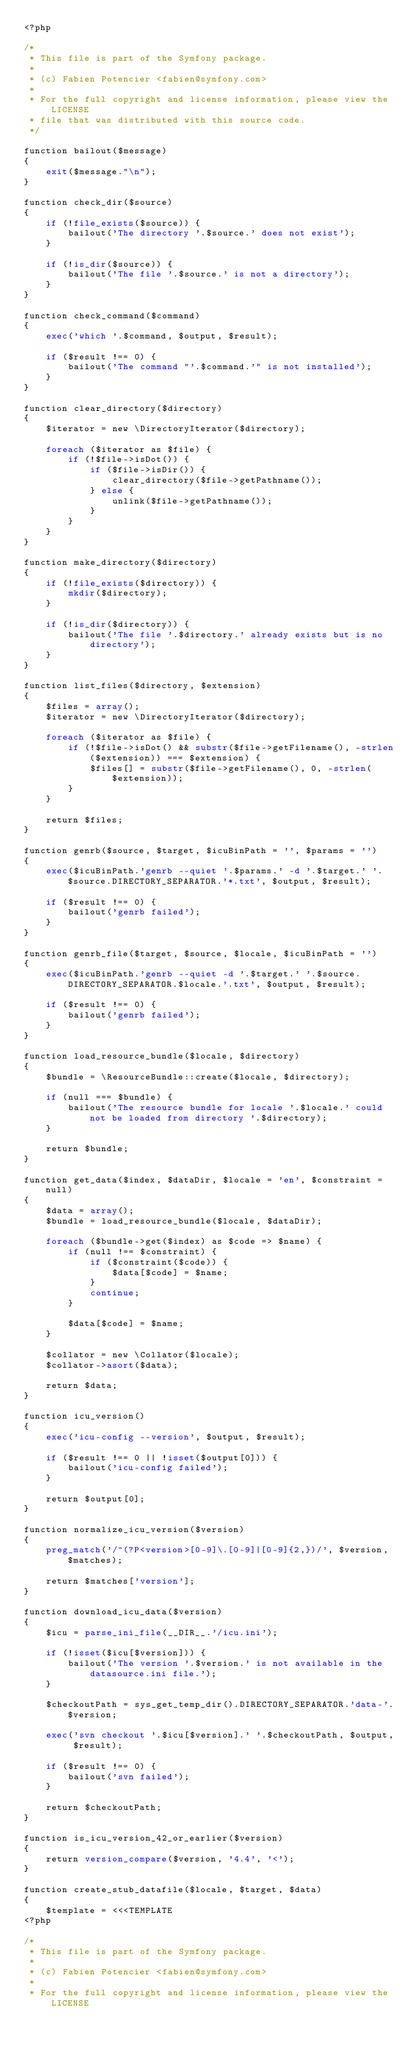Convert code to text. <code><loc_0><loc_0><loc_500><loc_500><_PHP_><?php

/*
 * This file is part of the Symfony package.
 *
 * (c) Fabien Potencier <fabien@symfony.com>
 *
 * For the full copyright and license information, please view the LICENSE
 * file that was distributed with this source code.
 */

function bailout($message)
{
    exit($message."\n");
}

function check_dir($source)
{
    if (!file_exists($source)) {
        bailout('The directory '.$source.' does not exist');
    }

    if (!is_dir($source)) {
        bailout('The file '.$source.' is not a directory');
    }
}

function check_command($command)
{
    exec('which '.$command, $output, $result);

    if ($result !== 0) {
        bailout('The command "'.$command.'" is not installed');
    }
}

function clear_directory($directory)
{
    $iterator = new \DirectoryIterator($directory);

    foreach ($iterator as $file) {
        if (!$file->isDot()) {
            if ($file->isDir()) {
                clear_directory($file->getPathname());
            } else {
                unlink($file->getPathname());
            }
        }
    }
}

function make_directory($directory)
{
    if (!file_exists($directory)) {
        mkdir($directory);
    }

    if (!is_dir($directory)) {
        bailout('The file '.$directory.' already exists but is no directory');
    }
}

function list_files($directory, $extension)
{
    $files = array();
    $iterator = new \DirectoryIterator($directory);

    foreach ($iterator as $file) {
        if (!$file->isDot() && substr($file->getFilename(), -strlen($extension)) === $extension) {
            $files[] = substr($file->getFilename(), 0, -strlen($extension));
        }
    }

    return $files;
}

function genrb($source, $target, $icuBinPath = '', $params = '')
{
    exec($icuBinPath.'genrb --quiet '.$params.' -d '.$target.' '.$source.DIRECTORY_SEPARATOR.'*.txt', $output, $result);

    if ($result !== 0) {
        bailout('genrb failed');
    }
}

function genrb_file($target, $source, $locale, $icuBinPath = '')
{
    exec($icuBinPath.'genrb --quiet -d '.$target.' '.$source.DIRECTORY_SEPARATOR.$locale.'.txt', $output, $result);

    if ($result !== 0) {
        bailout('genrb failed');
    }
}

function load_resource_bundle($locale, $directory)
{
    $bundle = \ResourceBundle::create($locale, $directory);

    if (null === $bundle) {
        bailout('The resource bundle for locale '.$locale.' could not be loaded from directory '.$directory);
    }

    return $bundle;
}

function get_data($index, $dataDir, $locale = 'en', $constraint = null)
{
    $data = array();
    $bundle = load_resource_bundle($locale, $dataDir);

    foreach ($bundle->get($index) as $code => $name) {
        if (null !== $constraint) {
            if ($constraint($code)) {
                $data[$code] = $name;
            }
            continue;
        }

        $data[$code] = $name;
    }

    $collator = new \Collator($locale);
    $collator->asort($data);

    return $data;
}

function icu_version()
{
    exec('icu-config --version', $output, $result);

    if ($result !== 0 || !isset($output[0])) {
        bailout('icu-config failed');
    }

    return $output[0];
}

function normalize_icu_version($version)
{
    preg_match('/^(?P<version>[0-9]\.[0-9]|[0-9]{2,})/', $version, $matches);

    return $matches['version'];
}

function download_icu_data($version)
{
    $icu = parse_ini_file(__DIR__.'/icu.ini');

    if (!isset($icu[$version])) {
        bailout('The version '.$version.' is not available in the datasource.ini file.');
    }

    $checkoutPath = sys_get_temp_dir().DIRECTORY_SEPARATOR.'data-'.$version;

    exec('svn checkout '.$icu[$version].' '.$checkoutPath, $output, $result);

    if ($result !== 0) {
        bailout('svn failed');
    }

    return $checkoutPath;
}

function is_icu_version_42_or_earlier($version)
{
    return version_compare($version, '4.4', '<');
}

function create_stub_datafile($locale, $target, $data)
{
    $template = <<<TEMPLATE
<?php

/*
 * This file is part of the Symfony package.
 *
 * (c) Fabien Potencier <fabien@symfony.com>
 *
 * For the full copyright and license information, please view the LICENSE</code> 